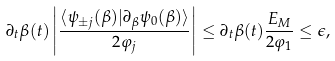<formula> <loc_0><loc_0><loc_500><loc_500>\partial _ { t } \beta ( t ) \left | \frac { \langle \psi _ { \pm j } ( \beta ) | \partial _ { \beta } \psi _ { 0 } ( \beta ) \rangle } { 2 \varphi _ { j } } \right | \leq \partial _ { t } \beta ( t ) \frac { E _ { M } } { 2 \varphi _ { 1 } } \leq \epsilon ,</formula> 